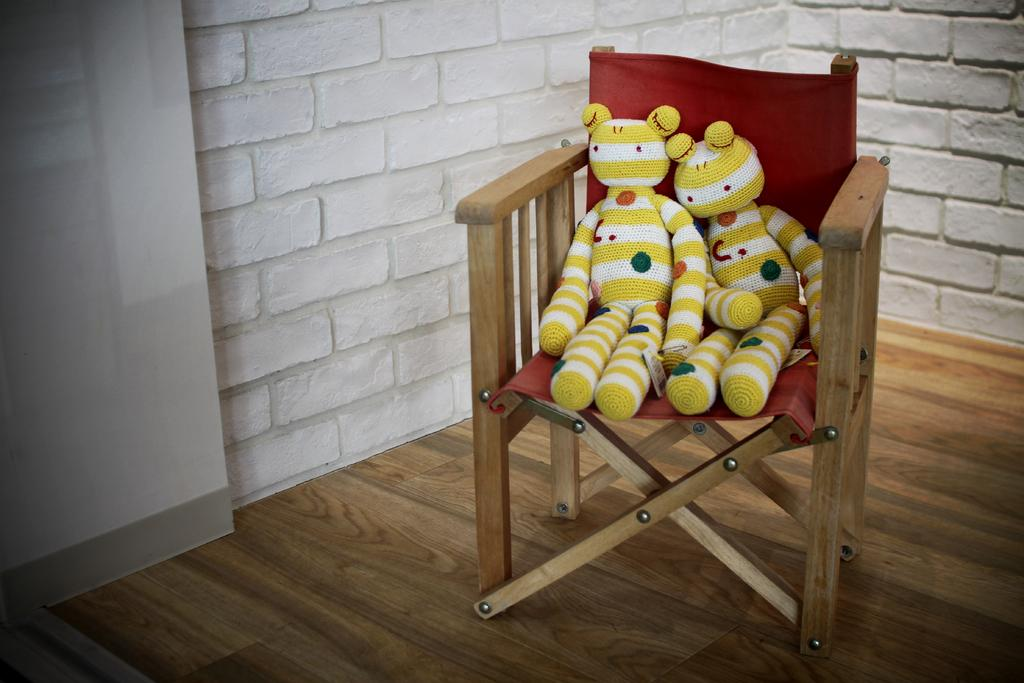How many toys are present in the image? There are two toys in the image. Where are the toys located? The toys are on a chair. What is the chair placed on in the image? The chair is on the wooden floor. What is visible behind the chair in the image? There is a wall visible behind the chair. What type of tax is being discussed in the image? There is no discussion of tax in the image; it features two toys on a chair. What industry is represented by the toys in the image? The image does not represent any specific industry; it simply shows two toys on a chair. 